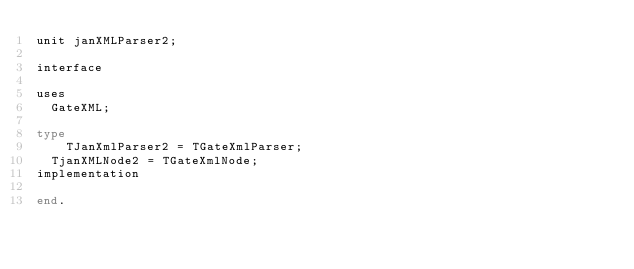<code> <loc_0><loc_0><loc_500><loc_500><_Pascal_>unit janXMLParser2;

interface

uses
  GateXML;

type
	TJanXmlParser2 = TGateXmlParser;
  TjanXMLNode2 = TGateXmlNode;
implementation

end.
</code> 